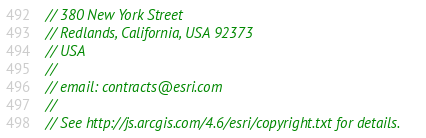<code> <loc_0><loc_0><loc_500><loc_500><_JavaScript_>// 380 New York Street
// Redlands, California, USA 92373
// USA
//
// email: contracts@esri.com
//
// See http://js.arcgis.com/4.6/esri/copyright.txt for details.
</code> 